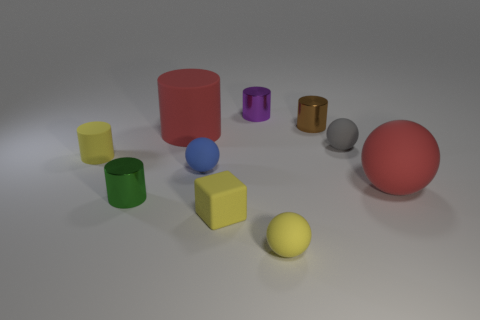Does the green cylinder have the same size as the metallic cylinder on the right side of the purple metallic cylinder?
Make the answer very short. Yes. How many other objects are the same color as the large cylinder?
Your answer should be compact. 1. There is a small brown shiny thing; are there any tiny blue rubber balls behind it?
Offer a very short reply. No. How many objects are green cylinders or small brown cylinders right of the large red matte cylinder?
Give a very brief answer. 2. There is a tiny yellow rubber thing that is left of the small block; are there any yellow things behind it?
Give a very brief answer. No. There is a red matte thing that is left of the small sphere left of the yellow rubber thing to the right of the rubber block; what shape is it?
Give a very brief answer. Cylinder. There is a small rubber object that is on the left side of the small gray matte thing and behind the blue object; what color is it?
Provide a short and direct response. Yellow. There is a large red object right of the small gray object; what shape is it?
Offer a terse response. Sphere. What is the shape of the brown thing that is the same material as the purple cylinder?
Provide a short and direct response. Cylinder. How many rubber objects are either cubes or small blue balls?
Offer a very short reply. 2. 